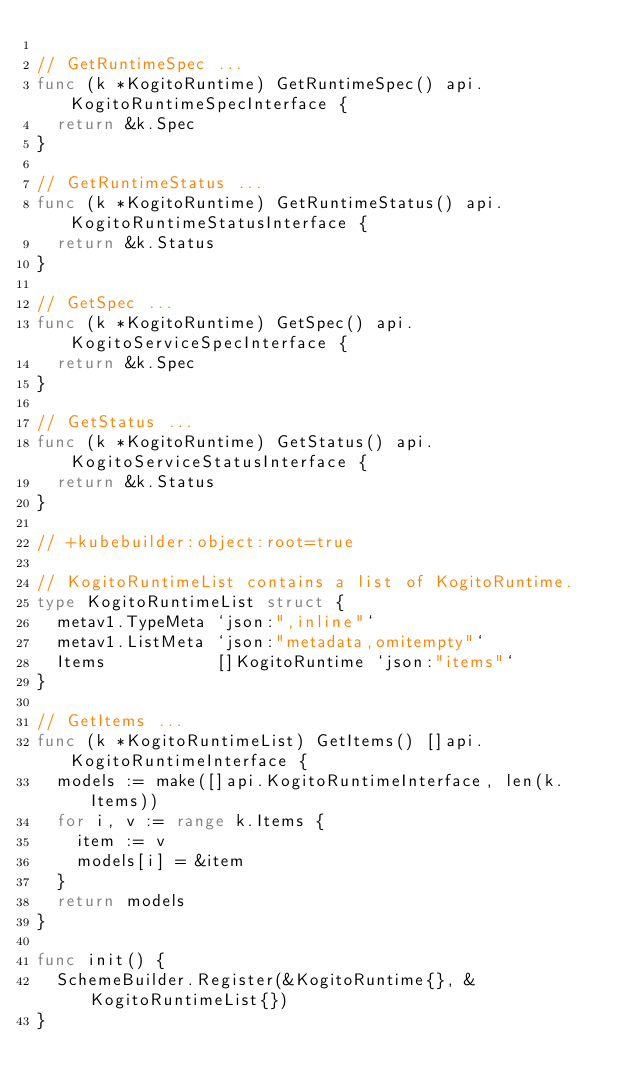Convert code to text. <code><loc_0><loc_0><loc_500><loc_500><_Go_>
// GetRuntimeSpec ...
func (k *KogitoRuntime) GetRuntimeSpec() api.KogitoRuntimeSpecInterface {
	return &k.Spec
}

// GetRuntimeStatus ...
func (k *KogitoRuntime) GetRuntimeStatus() api.KogitoRuntimeStatusInterface {
	return &k.Status
}

// GetSpec ...
func (k *KogitoRuntime) GetSpec() api.KogitoServiceSpecInterface {
	return &k.Spec
}

// GetStatus ...
func (k *KogitoRuntime) GetStatus() api.KogitoServiceStatusInterface {
	return &k.Status
}

// +kubebuilder:object:root=true

// KogitoRuntimeList contains a list of KogitoRuntime.
type KogitoRuntimeList struct {
	metav1.TypeMeta `json:",inline"`
	metav1.ListMeta `json:"metadata,omitempty"`
	Items           []KogitoRuntime `json:"items"`
}

// GetItems ...
func (k *KogitoRuntimeList) GetItems() []api.KogitoRuntimeInterface {
	models := make([]api.KogitoRuntimeInterface, len(k.Items))
	for i, v := range k.Items {
		item := v
		models[i] = &item
	}
	return models
}

func init() {
	SchemeBuilder.Register(&KogitoRuntime{}, &KogitoRuntimeList{})
}
</code> 